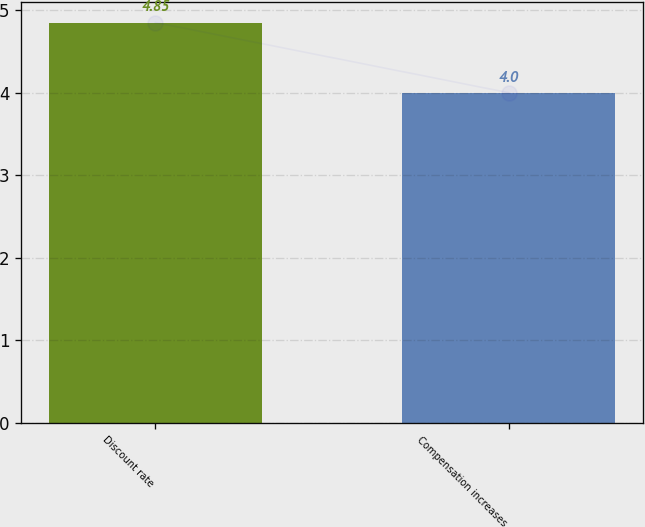Convert chart to OTSL. <chart><loc_0><loc_0><loc_500><loc_500><bar_chart><fcel>Discount rate<fcel>Compensation increases<nl><fcel>4.85<fcel>4<nl></chart> 